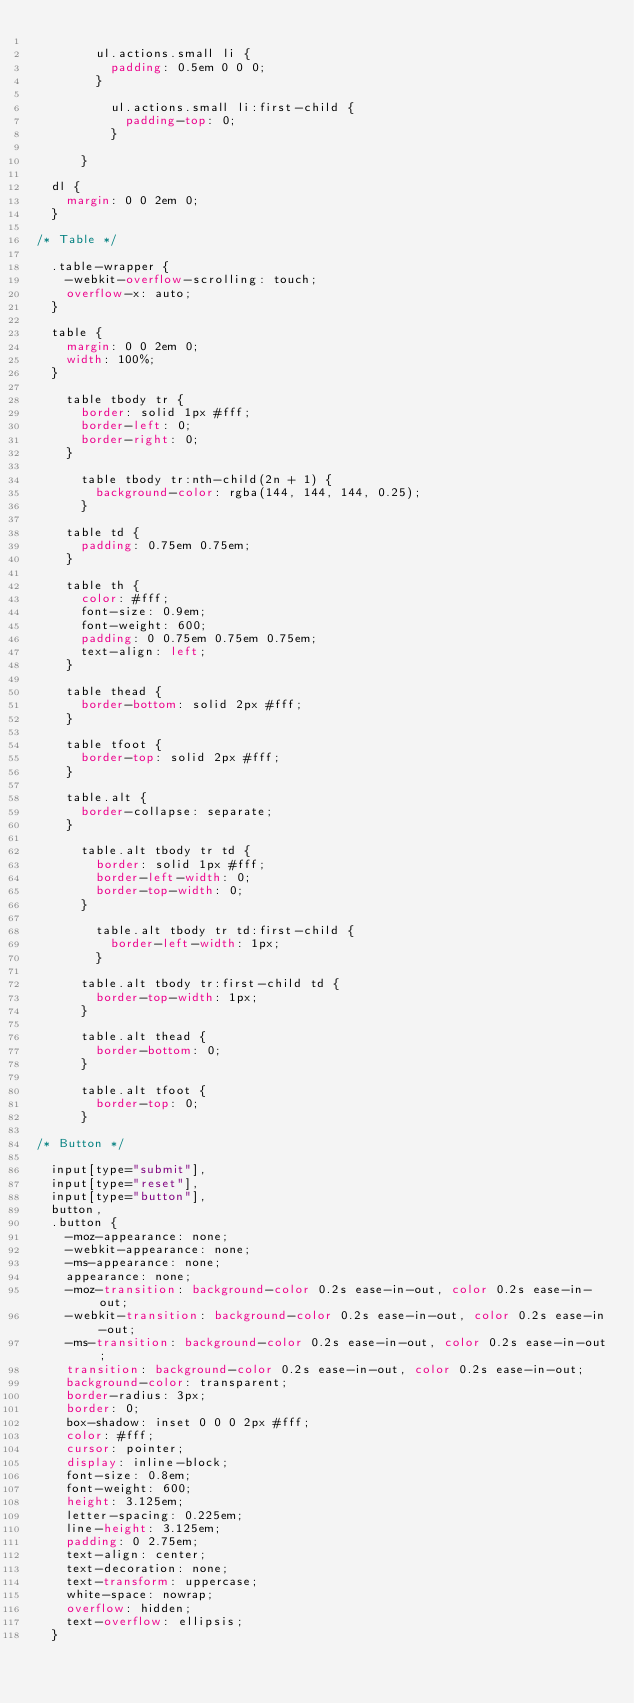Convert code to text. <code><loc_0><loc_0><loc_500><loc_500><_CSS_>
				ul.actions.small li {
					padding: 0.5em 0 0 0;
				}

					ul.actions.small li:first-child {
						padding-top: 0;
					}

			}

	dl {
		margin: 0 0 2em 0;
	}

/* Table */

	.table-wrapper {
		-webkit-overflow-scrolling: touch;
		overflow-x: auto;
	}

	table {
		margin: 0 0 2em 0;
		width: 100%;
	}

		table tbody tr {
			border: solid 1px #fff;
			border-left: 0;
			border-right: 0;
		}

			table tbody tr:nth-child(2n + 1) {
				background-color: rgba(144, 144, 144, 0.25);
			}

		table td {
			padding: 0.75em 0.75em;
		}

		table th {
			color: #fff;
			font-size: 0.9em;
			font-weight: 600;
			padding: 0 0.75em 0.75em 0.75em;
			text-align: left;
		}

		table thead {
			border-bottom: solid 2px #fff;
		}

		table tfoot {
			border-top: solid 2px #fff;
		}

		table.alt {
			border-collapse: separate;
		}

			table.alt tbody tr td {
				border: solid 1px #fff;
				border-left-width: 0;
				border-top-width: 0;
			}

				table.alt tbody tr td:first-child {
					border-left-width: 1px;
				}

			table.alt tbody tr:first-child td {
				border-top-width: 1px;
			}

			table.alt thead {
				border-bottom: 0;
			}

			table.alt tfoot {
				border-top: 0;
			}

/* Button */

	input[type="submit"],
	input[type="reset"],
	input[type="button"],
	button,
	.button {
		-moz-appearance: none;
		-webkit-appearance: none;
		-ms-appearance: none;
		appearance: none;
		-moz-transition: background-color 0.2s ease-in-out, color 0.2s ease-in-out;
		-webkit-transition: background-color 0.2s ease-in-out, color 0.2s ease-in-out;
		-ms-transition: background-color 0.2s ease-in-out, color 0.2s ease-in-out;
		transition: background-color 0.2s ease-in-out, color 0.2s ease-in-out;
		background-color: transparent;
		border-radius: 3px;
		border: 0;
		box-shadow: inset 0 0 0 2px #fff;
		color: #fff;
		cursor: pointer;
		display: inline-block;
		font-size: 0.8em;
		font-weight: 600;
		height: 3.125em;
		letter-spacing: 0.225em;
		line-height: 3.125em;
		padding: 0 2.75em;
		text-align: center;
		text-decoration: none;
		text-transform: uppercase;
		white-space: nowrap;
		overflow: hidden;
		text-overflow: ellipsis;
	}
</code> 